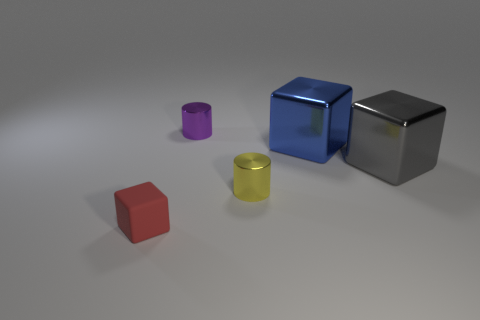Add 4 large blue shiny things. How many objects exist? 9 Subtract all cylinders. How many objects are left? 3 Subtract 1 blue cubes. How many objects are left? 4 Subtract all green objects. Subtract all metal blocks. How many objects are left? 3 Add 2 blue things. How many blue things are left? 3 Add 2 large blue metallic objects. How many large blue metallic objects exist? 3 